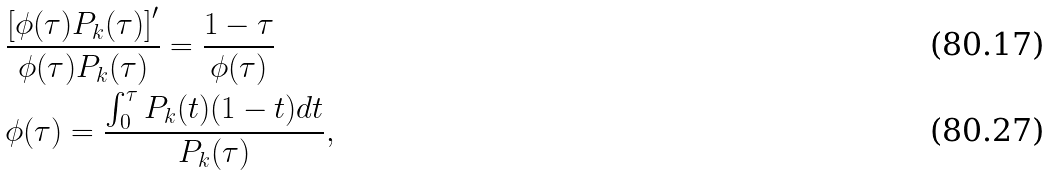<formula> <loc_0><loc_0><loc_500><loc_500>& \frac { \left [ \phi ( \tau ) P _ { k } ( \tau ) \right ] ^ { \prime } } { \phi ( \tau ) P _ { k } ( \tau ) } = \frac { 1 - \tau } { \phi ( \tau ) } \\ & \phi ( \tau ) = \frac { \int _ { 0 } ^ { \tau } P _ { k } ( t ) ( 1 - t ) d t } { P _ { k } ( \tau ) } ,</formula> 